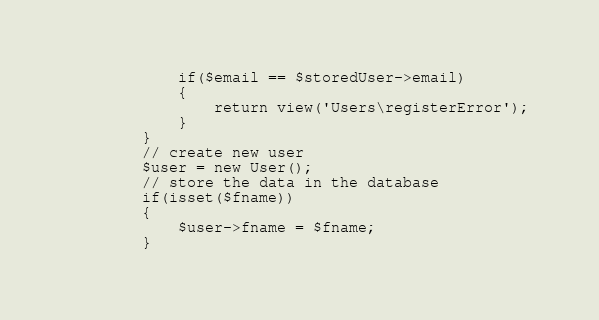Convert code to text. <code><loc_0><loc_0><loc_500><loc_500><_PHP_>            if($email == $storedUser->email)
            {
                return view('Users\registerError');
            }
        }
        // create new user
        $user = new User();
        // store the data in the database
        if(isset($fname))
        {
            $user->fname = $fname;
        }</code> 